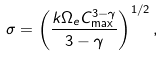<formula> <loc_0><loc_0><loc_500><loc_500>\sigma = \left ( \frac { k \Omega _ { e } C _ { \max } ^ { 3 - \gamma } } { 3 - \gamma } \right ) ^ { 1 / 2 } ,</formula> 